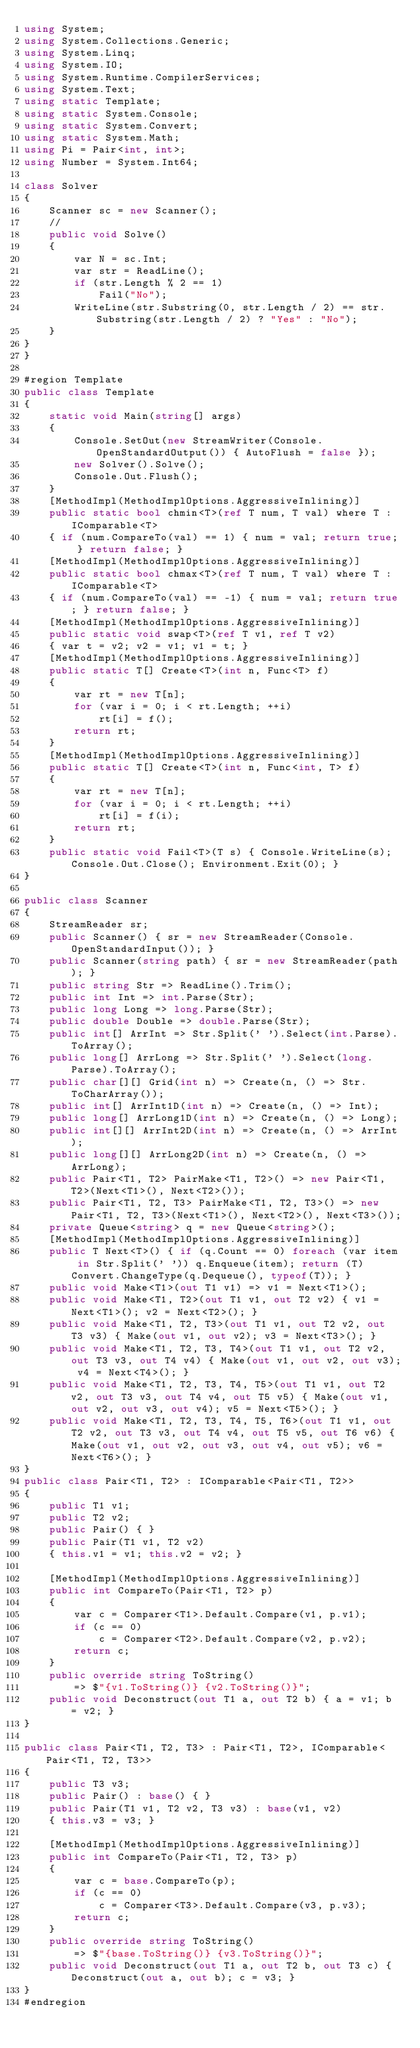<code> <loc_0><loc_0><loc_500><loc_500><_C#_>using System;
using System.Collections.Generic;
using System.Linq;
using System.IO;
using System.Runtime.CompilerServices;
using System.Text;
using static Template;
using static System.Console;
using static System.Convert;
using static System.Math;
using Pi = Pair<int, int>;
using Number = System.Int64;

class Solver
{
    Scanner sc = new Scanner();
    //
    public void Solve()
    {
        var N = sc.Int;
        var str = ReadLine();
        if (str.Length % 2 == 1)
            Fail("No");
        WriteLine(str.Substring(0, str.Length / 2) == str.Substring(str.Length / 2) ? "Yes" : "No");
    }
}
}

#region Template
public class Template
{
    static void Main(string[] args)
    {
        Console.SetOut(new StreamWriter(Console.OpenStandardOutput()) { AutoFlush = false });
        new Solver().Solve();
        Console.Out.Flush();
    }
    [MethodImpl(MethodImplOptions.AggressiveInlining)]
    public static bool chmin<T>(ref T num, T val) where T : IComparable<T>
    { if (num.CompareTo(val) == 1) { num = val; return true; } return false; }
    [MethodImpl(MethodImplOptions.AggressiveInlining)]
    public static bool chmax<T>(ref T num, T val) where T : IComparable<T>
    { if (num.CompareTo(val) == -1) { num = val; return true; } return false; }
    [MethodImpl(MethodImplOptions.AggressiveInlining)]
    public static void swap<T>(ref T v1, ref T v2)
    { var t = v2; v2 = v1; v1 = t; }
    [MethodImpl(MethodImplOptions.AggressiveInlining)]
    public static T[] Create<T>(int n, Func<T> f)
    {
        var rt = new T[n];
        for (var i = 0; i < rt.Length; ++i)
            rt[i] = f();
        return rt;
    }
    [MethodImpl(MethodImplOptions.AggressiveInlining)]
    public static T[] Create<T>(int n, Func<int, T> f)
    {
        var rt = new T[n];
        for (var i = 0; i < rt.Length; ++i)
            rt[i] = f(i);
        return rt;
    }
    public static void Fail<T>(T s) { Console.WriteLine(s); Console.Out.Close(); Environment.Exit(0); }
}

public class Scanner
{
    StreamReader sr;
    public Scanner() { sr = new StreamReader(Console.OpenStandardInput()); }
    public Scanner(string path) { sr = new StreamReader(path); }
    public string Str => ReadLine().Trim();
    public int Int => int.Parse(Str);
    public long Long => long.Parse(Str);
    public double Double => double.Parse(Str);
    public int[] ArrInt => Str.Split(' ').Select(int.Parse).ToArray();
    public long[] ArrLong => Str.Split(' ').Select(long.Parse).ToArray();
    public char[][] Grid(int n) => Create(n, () => Str.ToCharArray());
    public int[] ArrInt1D(int n) => Create(n, () => Int);
    public long[] ArrLong1D(int n) => Create(n, () => Long);
    public int[][] ArrInt2D(int n) => Create(n, () => ArrInt);
    public long[][] ArrLong2D(int n) => Create(n, () => ArrLong);
    public Pair<T1, T2> PairMake<T1, T2>() => new Pair<T1, T2>(Next<T1>(), Next<T2>());
    public Pair<T1, T2, T3> PairMake<T1, T2, T3>() => new Pair<T1, T2, T3>(Next<T1>(), Next<T2>(), Next<T3>());
    private Queue<string> q = new Queue<string>();
    [MethodImpl(MethodImplOptions.AggressiveInlining)]
    public T Next<T>() { if (q.Count == 0) foreach (var item in Str.Split(' ')) q.Enqueue(item); return (T)Convert.ChangeType(q.Dequeue(), typeof(T)); }
    public void Make<T1>(out T1 v1) => v1 = Next<T1>();
    public void Make<T1, T2>(out T1 v1, out T2 v2) { v1 = Next<T1>(); v2 = Next<T2>(); }
    public void Make<T1, T2, T3>(out T1 v1, out T2 v2, out T3 v3) { Make(out v1, out v2); v3 = Next<T3>(); }
    public void Make<T1, T2, T3, T4>(out T1 v1, out T2 v2, out T3 v3, out T4 v4) { Make(out v1, out v2, out v3); v4 = Next<T4>(); }
    public void Make<T1, T2, T3, T4, T5>(out T1 v1, out T2 v2, out T3 v3, out T4 v4, out T5 v5) { Make(out v1, out v2, out v3, out v4); v5 = Next<T5>(); }
    public void Make<T1, T2, T3, T4, T5, T6>(out T1 v1, out T2 v2, out T3 v3, out T4 v4, out T5 v5, out T6 v6) { Make(out v1, out v2, out v3, out v4, out v5); v6 = Next<T6>(); }
}
public class Pair<T1, T2> : IComparable<Pair<T1, T2>>
{
    public T1 v1;
    public T2 v2;
    public Pair() { }
    public Pair(T1 v1, T2 v2)
    { this.v1 = v1; this.v2 = v2; }

    [MethodImpl(MethodImplOptions.AggressiveInlining)]
    public int CompareTo(Pair<T1, T2> p)
    {
        var c = Comparer<T1>.Default.Compare(v1, p.v1);
        if (c == 0)
            c = Comparer<T2>.Default.Compare(v2, p.v2);
        return c;
    }
    public override string ToString()
        => $"{v1.ToString()} {v2.ToString()}";
    public void Deconstruct(out T1 a, out T2 b) { a = v1; b = v2; }
}

public class Pair<T1, T2, T3> : Pair<T1, T2>, IComparable<Pair<T1, T2, T3>>
{
    public T3 v3;
    public Pair() : base() { }
    public Pair(T1 v1, T2 v2, T3 v3) : base(v1, v2)
    { this.v3 = v3; }

    [MethodImpl(MethodImplOptions.AggressiveInlining)]
    public int CompareTo(Pair<T1, T2, T3> p)
    {
        var c = base.CompareTo(p);
        if (c == 0)
            c = Comparer<T3>.Default.Compare(v3, p.v3);
        return c;
    }
    public override string ToString()
        => $"{base.ToString()} {v3.ToString()}";
    public void Deconstruct(out T1 a, out T2 b, out T3 c) { Deconstruct(out a, out b); c = v3; }
}
#endregion
</code> 